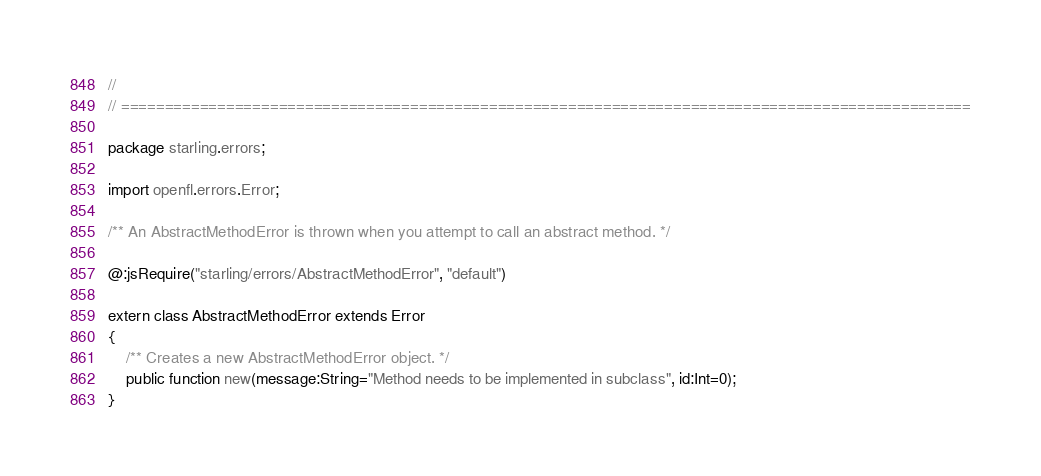Convert code to text. <code><loc_0><loc_0><loc_500><loc_500><_Haxe_>//
// =================================================================================================

package starling.errors;

import openfl.errors.Error;

/** An AbstractMethodError is thrown when you attempt to call an abstract method. */

@:jsRequire("starling/errors/AbstractMethodError", "default")

extern class AbstractMethodError extends Error
{
    /** Creates a new AbstractMethodError object. */
    public function new(message:String="Method needs to be implemented in subclass", id:Int=0);
}</code> 